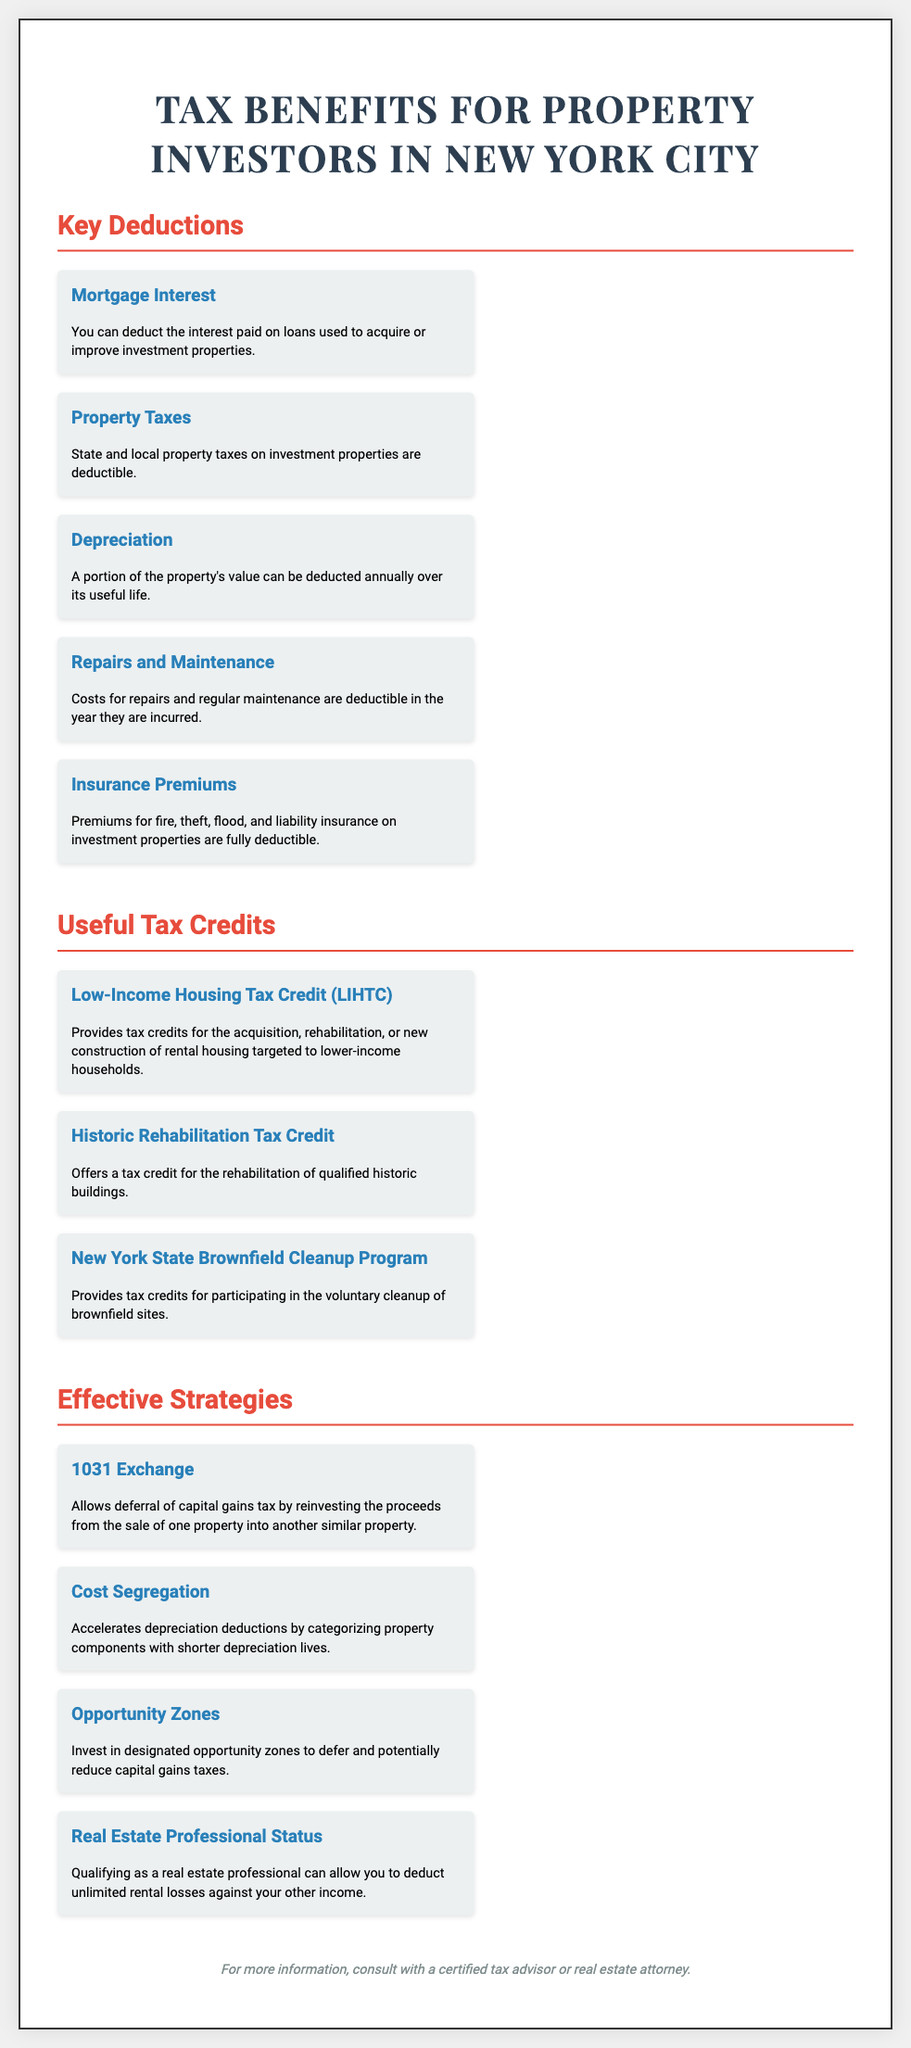What is the first key deduction listed? The first key deduction mentioned in the document is "Mortgage Interest."
Answer: Mortgage Interest What does the LIHTC stand for? LIHTC refers to the "Low-Income Housing Tax Credit."
Answer: Low-Income Housing Tax Credit How many useful tax credits are mentioned? There are three useful tax credits listed in the document.
Answer: Three What is a benefit of a 1031 Exchange? A 1031 Exchange allows the "deferral of capital gains tax."
Answer: Deferral of capital gains tax What type of property can allow unlimited rental losses to be deducted? Qualifying as a "real estate professional" can result in unlimited rental losses being deductible.
Answer: Real estate professional What tax credit is associated with historic buildings? The tax credit linked to historic buildings is the "Historic Rehabilitation Tax Credit."
Answer: Historic Rehabilitation Tax Credit Which strategy involves categorizing property components? The strategy that involves categorizing property components is "Cost Segregation."
Answer: Cost Segregation What must one consult for more information? For more information, one should consult with a "certified tax advisor or real estate attorney."
Answer: Certified tax advisor or real estate attorney What are property taxes classified as in the key deductions? Property taxes are classified as "deductible" in the key deductions section.
Answer: Deductible 